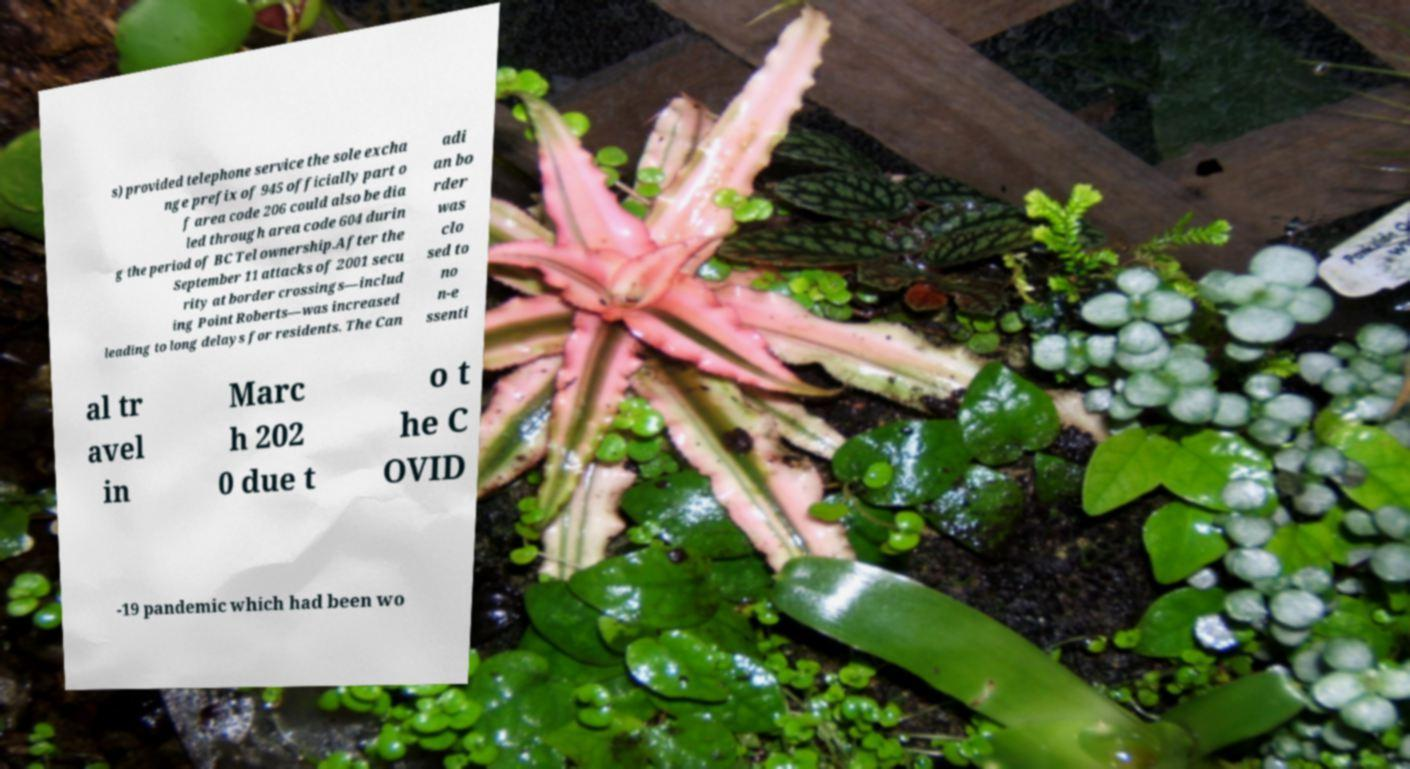Can you accurately transcribe the text from the provided image for me? s) provided telephone service the sole excha nge prefix of 945 officially part o f area code 206 could also be dia led through area code 604 durin g the period of BC Tel ownership.After the September 11 attacks of 2001 secu rity at border crossings—includ ing Point Roberts—was increased leading to long delays for residents. The Can adi an bo rder was clo sed to no n-e ssenti al tr avel in Marc h 202 0 due t o t he C OVID -19 pandemic which had been wo 